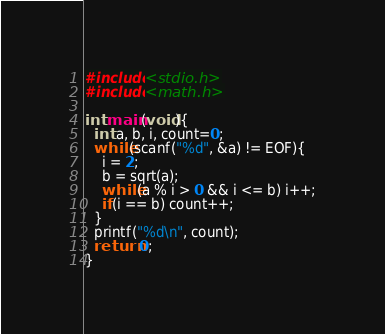Convert code to text. <code><loc_0><loc_0><loc_500><loc_500><_C_>#include<stdio.h>
#include<math.h>

int main(void){
  int a, b, i, count=0;
  while(scanf("%d", &a) != EOF){
    i = 2;
    b = sqrt(a);
    while(a % i > 0 && i <= b) i++;
    if(i == b) count++;
  }
  printf("%d\n", count);
  return 0;
}</code> 